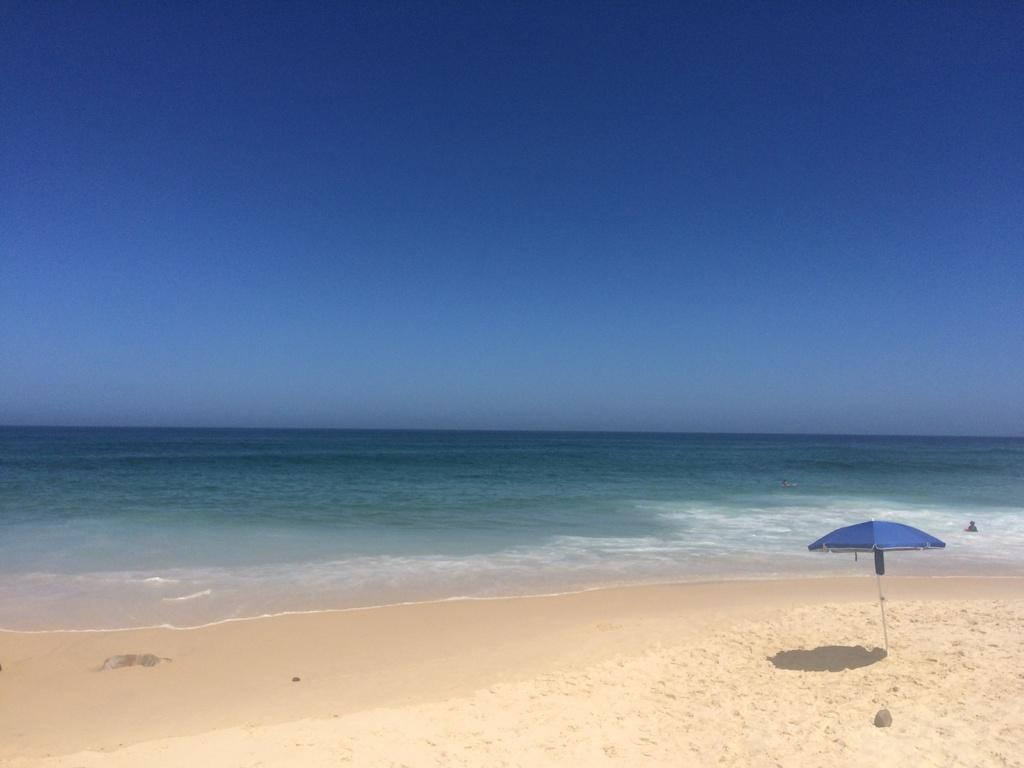What is the main object in the image? There is an umbrella in the image. What is located in the sand in the image? There is an object in the sand. What activity can be seen in the background of the image? People are swimming in the water in the background of the image. What is visible at the top of the image? The sky is visible at the top of the image. How many family members are holding the twig in the image? There is no twig or family members present in the image. What type of sugar is being used to sweeten the water in the image? There is no sugar or indication of sweetening the water in the image. 